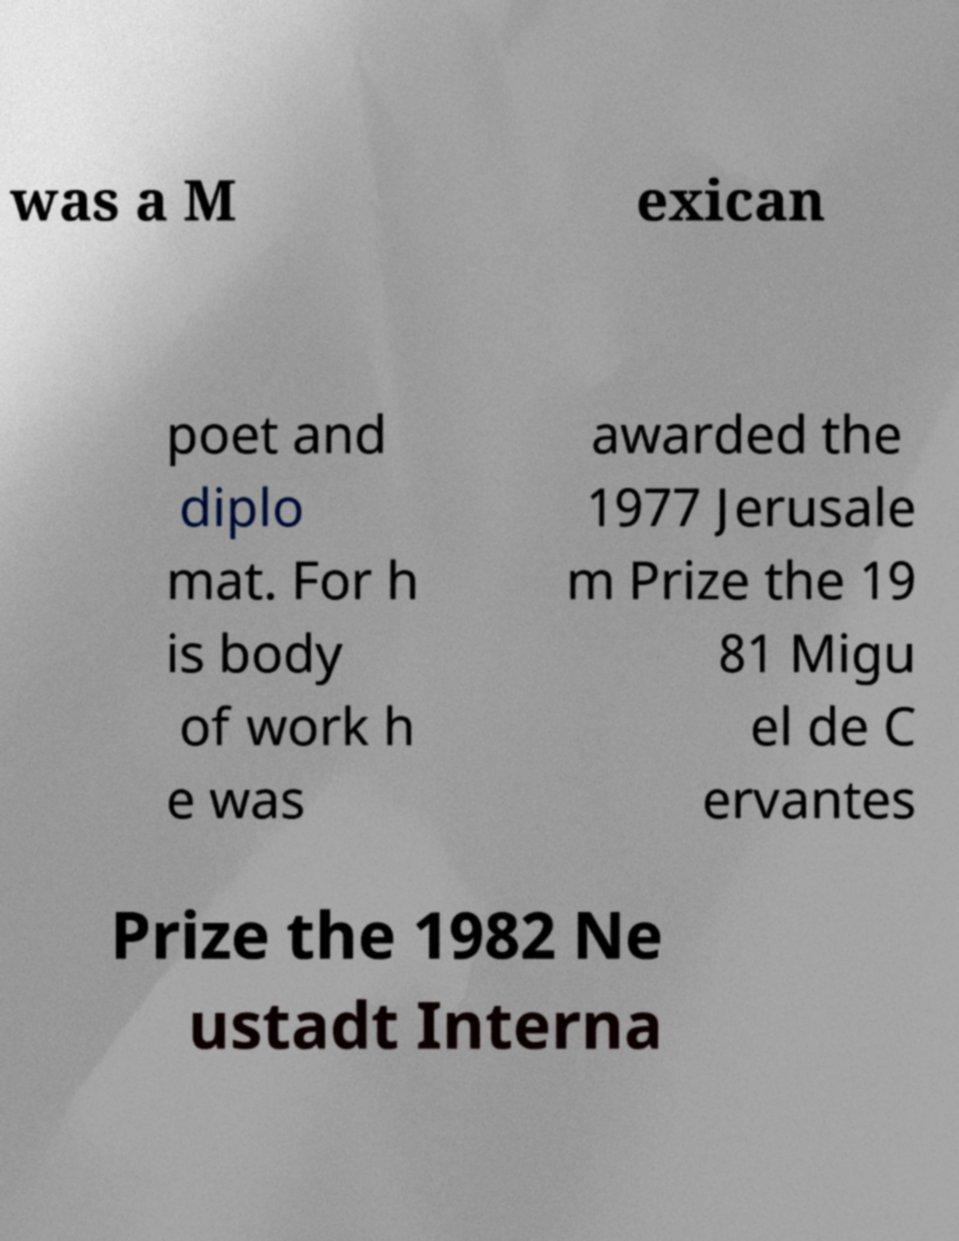Could you extract and type out the text from this image? was a M exican poet and diplo mat. For h is body of work h e was awarded the 1977 Jerusale m Prize the 19 81 Migu el de C ervantes Prize the 1982 Ne ustadt Interna 